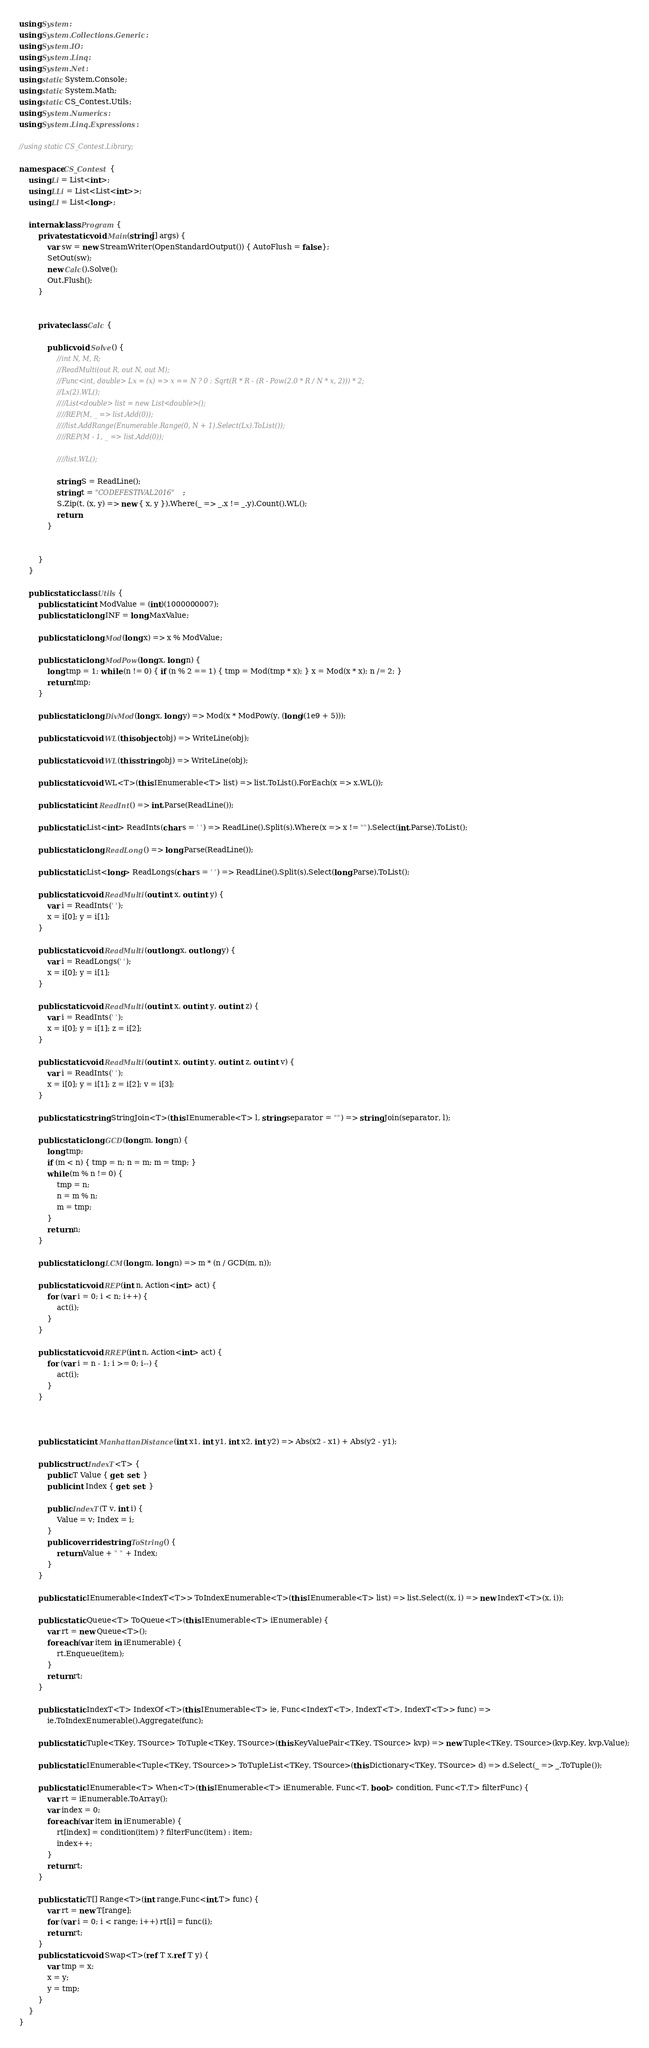<code> <loc_0><loc_0><loc_500><loc_500><_C#_>using System;
using System.Collections.Generic;
using System.IO;
using System.Linq;
using System.Net;
using static System.Console;
using static System.Math;
using static CS_Contest.Utils;
using System.Numerics;
using System.Linq.Expressions;

//using static CS_Contest.Library;

namespace CS_Contest {
	using Li = List<int>;
	using LLi = List<List<int>>;
	using Ll = List<long>;

	internal class Program {
		private static void Main(string[] args) {
			var sw = new StreamWriter(OpenStandardOutput()) { AutoFlush = false };
			SetOut(sw);
			new Calc().Solve();
			Out.Flush();
		}
		

		private class Calc {

			public void Solve() {
				//int N, M, R;
				//ReadMulti(out R, out N, out M);
				//Func<int, double> Lx = (x) => x == N ? 0 : Sqrt(R * R - (R - Pow(2.0 * R / N * x, 2))) * 2;
				//Lx(2).WL();
				////List<double> list = new List<double>();
				////REP(M, _ => list.Add(0));
				////list.AddRange(Enumerable.Range(0, N + 1).Select(Lx).ToList());
				////REP(M - 1, _ => list.Add(0));

				////list.WL();

				string S = ReadLine();
				string t = "CODEFESTIVAL2016";
				S.Zip(t, (x, y) => new { x, y }).Where(_ => _.x != _.y).Count().WL();
				return;
			}

			
		}
	}

	public static class Utils {
		public static int ModValue = (int)(1000000007);
		public static long INF = long.MaxValue;

		public static long Mod(long x) => x % ModValue;

		public static long ModPow(long x, long n) {
			long tmp = 1; while (n != 0) { if (n % 2 == 1) { tmp = Mod(tmp * x); } x = Mod(x * x); n /= 2; }
			return tmp;
		}

		public static long DivMod(long x, long y) => Mod(x * ModPow(y, (long)(1e9 + 5)));

		public static void WL(this object obj) => WriteLine(obj);

		public static void WL(this string obj) => WriteLine(obj);

		public static void WL<T>(this IEnumerable<T> list) => list.ToList().ForEach(x => x.WL());

		public static int ReadInt() => int.Parse(ReadLine());

		public static List<int> ReadInts(char s = ' ') => ReadLine().Split(s).Where(x => x != "").Select(int.Parse).ToList();

		public static long ReadLong() => long.Parse(ReadLine());

		public static List<long> ReadLongs(char s = ' ') => ReadLine().Split(s).Select(long.Parse).ToList();

		public static void ReadMulti(out int x, out int y) {
			var i = ReadInts(' ');
			x = i[0]; y = i[1];
		}

		public static void ReadMulti(out long x, out long y) {
			var i = ReadLongs(' ');
			x = i[0]; y = i[1];
		}

		public static void ReadMulti(out int x, out int y, out int z) {
			var i = ReadInts(' ');
			x = i[0]; y = i[1]; z = i[2];
		}

		public static void ReadMulti(out int x, out int y, out int z, out int v) {
			var i = ReadInts(' ');
			x = i[0]; y = i[1]; z = i[2]; v = i[3];
		}

		public static string StringJoin<T>(this IEnumerable<T> l, string separator = "") => string.Join(separator, l);

		public static long GCD(long m, long n) {
			long tmp;
			if (m < n) { tmp = n; n = m; m = tmp; }
			while (m % n != 0) {
				tmp = n;
				n = m % n;
				m = tmp;
			}
			return n;
		}

		public static long LCM(long m, long n) => m * (n / GCD(m, n));

		public static void REP(int n, Action<int> act) {
			for (var i = 0; i < n; i++) {
				act(i);
			}
		}

		public static void RREP(int n, Action<int> act) {
			for (var i = n - 1; i >= 0; i--) {
				act(i);
			}
		}



		public static int ManhattanDistance(int x1, int y1, int x2, int y2) => Abs(x2 - x1) + Abs(y2 - y1);

		public struct IndexT<T> {
			public T Value { get; set; }
			public int Index { get; set; }

			public IndexT(T v, int i) {
				Value = v; Index = i;
			}
			public override string ToString() {
				return Value + " " + Index;
			}
		}

		public static IEnumerable<IndexT<T>> ToIndexEnumerable<T>(this IEnumerable<T> list) => list.Select((x, i) => new IndexT<T>(x, i));

		public static Queue<T> ToQueue<T>(this IEnumerable<T> iEnumerable) {
			var rt = new Queue<T>();
			foreach (var item in iEnumerable) {
				rt.Enqueue(item);
			}
			return rt;
		}

		public static IndexT<T> IndexOf<T>(this IEnumerable<T> ie, Func<IndexT<T>, IndexT<T>, IndexT<T>> func) =>
			ie.ToIndexEnumerable().Aggregate(func);

		public static Tuple<TKey, TSource> ToTuple<TKey, TSource>(this KeyValuePair<TKey, TSource> kvp) => new Tuple<TKey, TSource>(kvp.Key, kvp.Value);

		public static IEnumerable<Tuple<TKey, TSource>> ToTupleList<TKey, TSource>(this Dictionary<TKey, TSource> d) => d.Select(_ => _.ToTuple());

		public static IEnumerable<T> When<T>(this IEnumerable<T> iEnumerable, Func<T, bool> condition, Func<T,T> filterFunc) {
			var rt = iEnumerable.ToArray();
			var index = 0;
			foreach (var item in iEnumerable) {
				rt[index] = condition(item) ? filterFunc(item) : item;
				index++;
			}
			return rt;
		}

		public static T[] Range<T>(int range,Func<int,T> func) {
			var rt = new T[range];
			for (var i = 0; i < range; i++) rt[i] = func(i);
			return rt;
		}
		public static void Swap<T>(ref T x,ref T y) {
			var tmp = x;
			x = y;
			y = tmp;
		}
	}
}</code> 